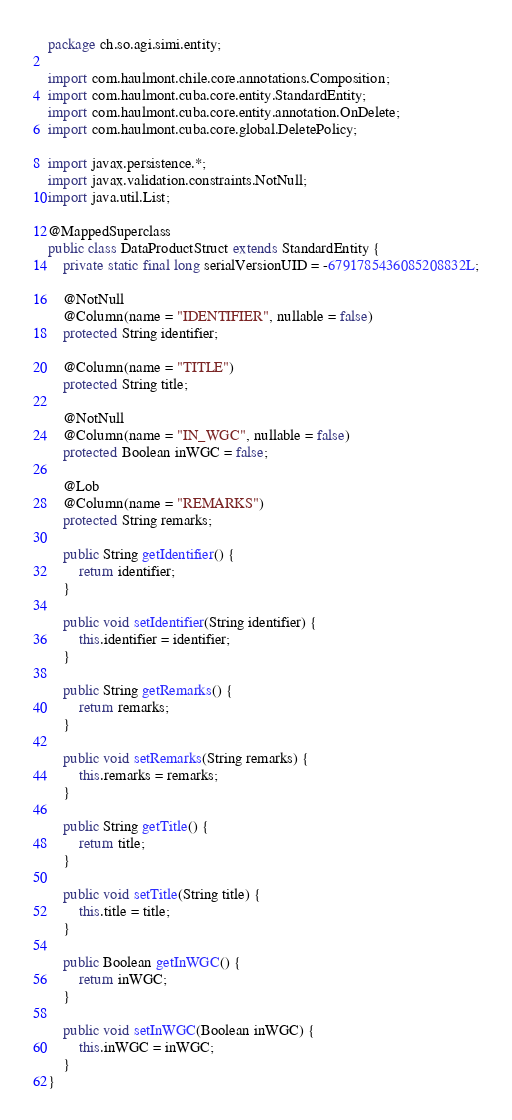<code> <loc_0><loc_0><loc_500><loc_500><_Java_>package ch.so.agi.simi.entity;

import com.haulmont.chile.core.annotations.Composition;
import com.haulmont.cuba.core.entity.StandardEntity;
import com.haulmont.cuba.core.entity.annotation.OnDelete;
import com.haulmont.cuba.core.global.DeletePolicy;

import javax.persistence.*;
import javax.validation.constraints.NotNull;
import java.util.List;

@MappedSuperclass
public class DataProductStruct extends StandardEntity {
    private static final long serialVersionUID = -6791785436085208832L;

    @NotNull
    @Column(name = "IDENTIFIER", nullable = false)
    protected String identifier;

    @Column(name = "TITLE")
    protected String title;

    @NotNull
    @Column(name = "IN_WGC", nullable = false)
    protected Boolean inWGC = false;

    @Lob
    @Column(name = "REMARKS")
    protected String remarks;

    public String getIdentifier() {
        return identifier;
    }

    public void setIdentifier(String identifier) {
        this.identifier = identifier;
    }

    public String getRemarks() {
        return remarks;
    }

    public void setRemarks(String remarks) {
        this.remarks = remarks;
    }

    public String getTitle() {
        return title;
    }

    public void setTitle(String title) {
        this.title = title;
    }

    public Boolean getInWGC() {
        return inWGC;
    }

    public void setInWGC(Boolean inWGC) {
        this.inWGC = inWGC;
    }
}</code> 